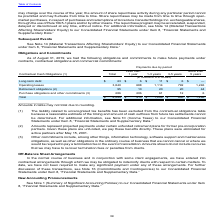According to Accenture Plc's financial document, What is the company's long-term debt due in 3-5 years? According to the financial document, $6 (in millions). The relevant text states: "Long-term debt $ 23 $ 6 $ 11 $ 6 $ —..." Also, What does the company's retirement obligations refer to? projected payments under certain unfunded retirement plans for former pre-incorporation partners.. The document states: "(2) Amounts represent projected payments under certain unfunded retirement plans for former pre-incorporation partners. Given these plans are unfunded..." Also, What is the company's total contractual cash obligations due in more than 5 years? According to the financial document, $1,296 (in millions). The relevant text states: "Total $ 4,244 $ 910 $ 1,206 $ 830 $ 1,296..." Also, can you calculate: What is the proportion of the company's total long term debt as a ratio of its total contractual cash obligations? Based on the calculation: (23/4,244), the result is 0.54 (percentage). This is based on the information: "Total $ 4,244 $ 910 $ 1,206 $ 830 $ 1,296 Long-term debt $ 23 $ 6 $ 11 $ 6 $ —..." The key data points involved are: 23, 4,244. Also, can you calculate: What is the total contractual cash obligation due in less than one year from long-term debt and operating leases? Based on the calculation: $23 + $3,840 , the result is 3863 (in millions). This is based on the information: "Operating leases 3,840 688 1,114 792 1,246 Long-term debt $ 23 $ 6 $ 11 $ 6 $ —..." The key data points involved are: 23, 3,840. Also, can you calculate: How much does operating leases account for total contractual cash obligations for period of less than 1 year? Based on the calculation: $688/910 , the result is 75.6 (percentage). This is based on the information: "Operating leases 3,840 688 1,114 792 1,246 Total $ 4,244 $ 910 $ 1,206 $ 830 $ 1,296..." The key data points involved are: 688, 910. 